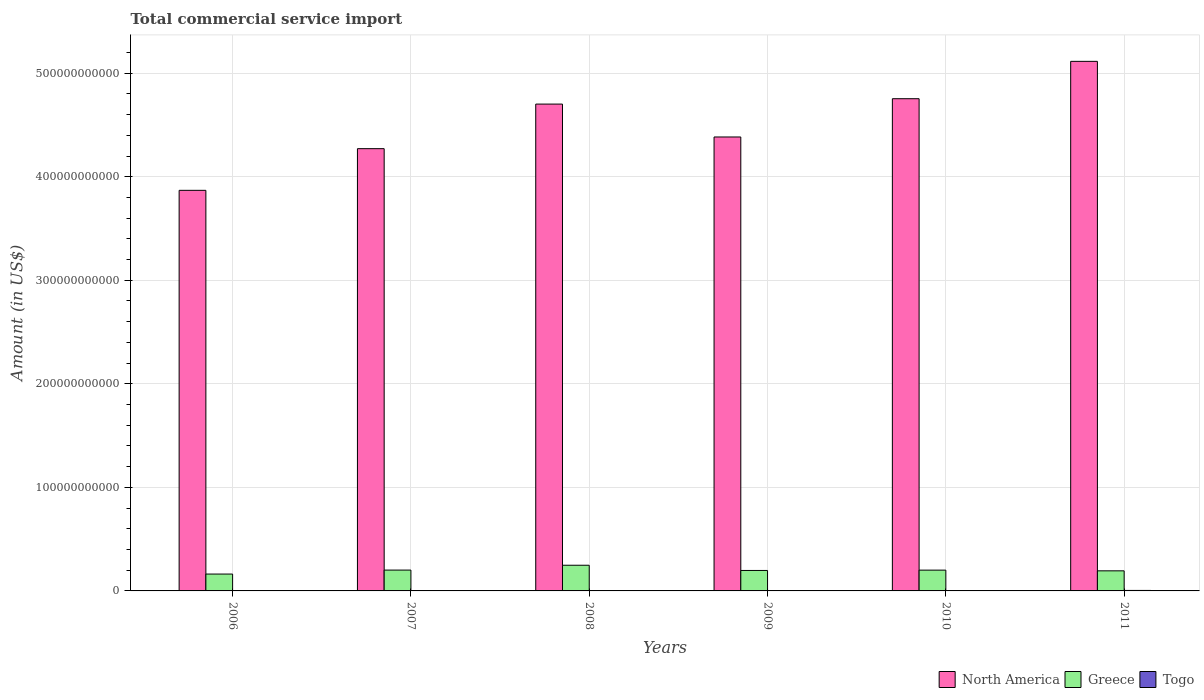How many different coloured bars are there?
Your answer should be very brief. 3. Are the number of bars per tick equal to the number of legend labels?
Give a very brief answer. Yes. Are the number of bars on each tick of the X-axis equal?
Your response must be concise. Yes. How many bars are there on the 2nd tick from the left?
Provide a short and direct response. 3. In how many cases, is the number of bars for a given year not equal to the number of legend labels?
Your answer should be very brief. 0. What is the total commercial service import in Togo in 2011?
Ensure brevity in your answer.  4.67e+08. Across all years, what is the maximum total commercial service import in North America?
Provide a succinct answer. 5.11e+11. Across all years, what is the minimum total commercial service import in North America?
Keep it short and to the point. 3.87e+11. In which year was the total commercial service import in Togo minimum?
Make the answer very short. 2006. What is the total total commercial service import in Greece in the graph?
Your response must be concise. 1.20e+11. What is the difference between the total commercial service import in Greece in 2007 and that in 2010?
Give a very brief answer. 3.73e+07. What is the difference between the total commercial service import in Togo in 2009 and the total commercial service import in Greece in 2006?
Provide a succinct answer. -1.59e+1. What is the average total commercial service import in Togo per year?
Provide a short and direct response. 3.60e+08. In the year 2011, what is the difference between the total commercial service import in Greece and total commercial service import in Togo?
Your response must be concise. 1.89e+1. What is the ratio of the total commercial service import in North America in 2006 to that in 2009?
Provide a succinct answer. 0.88. Is the difference between the total commercial service import in Greece in 2006 and 2008 greater than the difference between the total commercial service import in Togo in 2006 and 2008?
Provide a succinct answer. No. What is the difference between the highest and the second highest total commercial service import in Greece?
Give a very brief answer. 4.68e+09. What is the difference between the highest and the lowest total commercial service import in Greece?
Your response must be concise. 8.51e+09. Is the sum of the total commercial service import in Togo in 2010 and 2011 greater than the maximum total commercial service import in North America across all years?
Keep it short and to the point. No. What does the 3rd bar from the left in 2006 represents?
Offer a terse response. Togo. Is it the case that in every year, the sum of the total commercial service import in Greece and total commercial service import in North America is greater than the total commercial service import in Togo?
Provide a succinct answer. Yes. Are all the bars in the graph horizontal?
Provide a succinct answer. No. How many years are there in the graph?
Your answer should be compact. 6. What is the difference between two consecutive major ticks on the Y-axis?
Make the answer very short. 1.00e+11. Are the values on the major ticks of Y-axis written in scientific E-notation?
Offer a terse response. No. Does the graph contain any zero values?
Provide a succinct answer. No. What is the title of the graph?
Keep it short and to the point. Total commercial service import. Does "Uruguay" appear as one of the legend labels in the graph?
Keep it short and to the point. No. What is the label or title of the X-axis?
Provide a short and direct response. Years. What is the label or title of the Y-axis?
Your response must be concise. Amount (in US$). What is the Amount (in US$) in North America in 2006?
Make the answer very short. 3.87e+11. What is the Amount (in US$) of Greece in 2006?
Keep it short and to the point. 1.63e+1. What is the Amount (in US$) in Togo in 2006?
Your answer should be compact. 2.61e+08. What is the Amount (in US$) in North America in 2007?
Provide a succinct answer. 4.27e+11. What is the Amount (in US$) in Greece in 2007?
Your response must be concise. 2.01e+1. What is the Amount (in US$) in Togo in 2007?
Keep it short and to the point. 3.03e+08. What is the Amount (in US$) in North America in 2008?
Ensure brevity in your answer.  4.70e+11. What is the Amount (in US$) of Greece in 2008?
Ensure brevity in your answer.  2.48e+1. What is the Amount (in US$) in Togo in 2008?
Provide a short and direct response. 3.58e+08. What is the Amount (in US$) in North America in 2009?
Offer a very short reply. 4.38e+11. What is the Amount (in US$) of Greece in 2009?
Provide a short and direct response. 1.98e+1. What is the Amount (in US$) of Togo in 2009?
Provide a succinct answer. 3.74e+08. What is the Amount (in US$) of North America in 2010?
Provide a succinct answer. 4.75e+11. What is the Amount (in US$) of Greece in 2010?
Give a very brief answer. 2.01e+1. What is the Amount (in US$) of Togo in 2010?
Offer a very short reply. 3.95e+08. What is the Amount (in US$) in North America in 2011?
Offer a very short reply. 5.11e+11. What is the Amount (in US$) of Greece in 2011?
Your response must be concise. 1.94e+1. What is the Amount (in US$) of Togo in 2011?
Offer a very short reply. 4.67e+08. Across all years, what is the maximum Amount (in US$) of North America?
Your response must be concise. 5.11e+11. Across all years, what is the maximum Amount (in US$) in Greece?
Provide a short and direct response. 2.48e+1. Across all years, what is the maximum Amount (in US$) in Togo?
Offer a very short reply. 4.67e+08. Across all years, what is the minimum Amount (in US$) of North America?
Your answer should be very brief. 3.87e+11. Across all years, what is the minimum Amount (in US$) of Greece?
Give a very brief answer. 1.63e+1. Across all years, what is the minimum Amount (in US$) of Togo?
Make the answer very short. 2.61e+08. What is the total Amount (in US$) of North America in the graph?
Offer a terse response. 2.71e+12. What is the total Amount (in US$) in Greece in the graph?
Ensure brevity in your answer.  1.20e+11. What is the total Amount (in US$) of Togo in the graph?
Your response must be concise. 2.16e+09. What is the difference between the Amount (in US$) of North America in 2006 and that in 2007?
Your response must be concise. -4.02e+1. What is the difference between the Amount (in US$) in Greece in 2006 and that in 2007?
Provide a short and direct response. -3.83e+09. What is the difference between the Amount (in US$) of Togo in 2006 and that in 2007?
Your answer should be very brief. -4.21e+07. What is the difference between the Amount (in US$) in North America in 2006 and that in 2008?
Keep it short and to the point. -8.33e+1. What is the difference between the Amount (in US$) in Greece in 2006 and that in 2008?
Give a very brief answer. -8.51e+09. What is the difference between the Amount (in US$) in Togo in 2006 and that in 2008?
Ensure brevity in your answer.  -9.65e+07. What is the difference between the Amount (in US$) of North America in 2006 and that in 2009?
Your answer should be compact. -5.15e+1. What is the difference between the Amount (in US$) of Greece in 2006 and that in 2009?
Give a very brief answer. -3.47e+09. What is the difference between the Amount (in US$) in Togo in 2006 and that in 2009?
Your response must be concise. -1.13e+08. What is the difference between the Amount (in US$) of North America in 2006 and that in 2010?
Provide a succinct answer. -8.85e+1. What is the difference between the Amount (in US$) of Greece in 2006 and that in 2010?
Give a very brief answer. -3.79e+09. What is the difference between the Amount (in US$) in Togo in 2006 and that in 2010?
Give a very brief answer. -1.34e+08. What is the difference between the Amount (in US$) of North America in 2006 and that in 2011?
Give a very brief answer. -1.25e+11. What is the difference between the Amount (in US$) of Greece in 2006 and that in 2011?
Your answer should be compact. -3.11e+09. What is the difference between the Amount (in US$) in Togo in 2006 and that in 2011?
Your answer should be very brief. -2.06e+08. What is the difference between the Amount (in US$) in North America in 2007 and that in 2008?
Keep it short and to the point. -4.30e+1. What is the difference between the Amount (in US$) in Greece in 2007 and that in 2008?
Your answer should be compact. -4.68e+09. What is the difference between the Amount (in US$) in Togo in 2007 and that in 2008?
Provide a short and direct response. -5.44e+07. What is the difference between the Amount (in US$) in North America in 2007 and that in 2009?
Offer a terse response. -1.13e+1. What is the difference between the Amount (in US$) of Greece in 2007 and that in 2009?
Ensure brevity in your answer.  3.55e+08. What is the difference between the Amount (in US$) of Togo in 2007 and that in 2009?
Offer a terse response. -7.10e+07. What is the difference between the Amount (in US$) of North America in 2007 and that in 2010?
Ensure brevity in your answer.  -4.82e+1. What is the difference between the Amount (in US$) in Greece in 2007 and that in 2010?
Make the answer very short. 3.73e+07. What is the difference between the Amount (in US$) in Togo in 2007 and that in 2010?
Your answer should be very brief. -9.20e+07. What is the difference between the Amount (in US$) in North America in 2007 and that in 2011?
Your response must be concise. -8.43e+1. What is the difference between the Amount (in US$) in Greece in 2007 and that in 2011?
Offer a terse response. 7.17e+08. What is the difference between the Amount (in US$) in Togo in 2007 and that in 2011?
Your answer should be compact. -1.64e+08. What is the difference between the Amount (in US$) in North America in 2008 and that in 2009?
Ensure brevity in your answer.  3.18e+1. What is the difference between the Amount (in US$) of Greece in 2008 and that in 2009?
Give a very brief answer. 5.04e+09. What is the difference between the Amount (in US$) in Togo in 2008 and that in 2009?
Make the answer very short. -1.66e+07. What is the difference between the Amount (in US$) in North America in 2008 and that in 2010?
Offer a terse response. -5.18e+09. What is the difference between the Amount (in US$) of Greece in 2008 and that in 2010?
Keep it short and to the point. 4.72e+09. What is the difference between the Amount (in US$) in Togo in 2008 and that in 2010?
Your response must be concise. -3.77e+07. What is the difference between the Amount (in US$) in North America in 2008 and that in 2011?
Make the answer very short. -4.13e+1. What is the difference between the Amount (in US$) of Greece in 2008 and that in 2011?
Provide a succinct answer. 5.40e+09. What is the difference between the Amount (in US$) in Togo in 2008 and that in 2011?
Offer a very short reply. -1.10e+08. What is the difference between the Amount (in US$) in North America in 2009 and that in 2010?
Provide a succinct answer. -3.70e+1. What is the difference between the Amount (in US$) of Greece in 2009 and that in 2010?
Give a very brief answer. -3.17e+08. What is the difference between the Amount (in US$) in Togo in 2009 and that in 2010?
Offer a very short reply. -2.11e+07. What is the difference between the Amount (in US$) in North America in 2009 and that in 2011?
Your response must be concise. -7.30e+1. What is the difference between the Amount (in US$) in Greece in 2009 and that in 2011?
Make the answer very short. 3.62e+08. What is the difference between the Amount (in US$) in Togo in 2009 and that in 2011?
Offer a very short reply. -9.32e+07. What is the difference between the Amount (in US$) of North America in 2010 and that in 2011?
Give a very brief answer. -3.61e+1. What is the difference between the Amount (in US$) in Greece in 2010 and that in 2011?
Make the answer very short. 6.79e+08. What is the difference between the Amount (in US$) in Togo in 2010 and that in 2011?
Keep it short and to the point. -7.21e+07. What is the difference between the Amount (in US$) of North America in 2006 and the Amount (in US$) of Greece in 2007?
Your response must be concise. 3.67e+11. What is the difference between the Amount (in US$) of North America in 2006 and the Amount (in US$) of Togo in 2007?
Offer a terse response. 3.87e+11. What is the difference between the Amount (in US$) of Greece in 2006 and the Amount (in US$) of Togo in 2007?
Offer a terse response. 1.60e+1. What is the difference between the Amount (in US$) in North America in 2006 and the Amount (in US$) in Greece in 2008?
Offer a very short reply. 3.62e+11. What is the difference between the Amount (in US$) of North America in 2006 and the Amount (in US$) of Togo in 2008?
Ensure brevity in your answer.  3.86e+11. What is the difference between the Amount (in US$) in Greece in 2006 and the Amount (in US$) in Togo in 2008?
Offer a terse response. 1.59e+1. What is the difference between the Amount (in US$) of North America in 2006 and the Amount (in US$) of Greece in 2009?
Your answer should be compact. 3.67e+11. What is the difference between the Amount (in US$) in North America in 2006 and the Amount (in US$) in Togo in 2009?
Keep it short and to the point. 3.86e+11. What is the difference between the Amount (in US$) of Greece in 2006 and the Amount (in US$) of Togo in 2009?
Your answer should be very brief. 1.59e+1. What is the difference between the Amount (in US$) of North America in 2006 and the Amount (in US$) of Greece in 2010?
Your answer should be compact. 3.67e+11. What is the difference between the Amount (in US$) in North America in 2006 and the Amount (in US$) in Togo in 2010?
Your answer should be compact. 3.86e+11. What is the difference between the Amount (in US$) in Greece in 2006 and the Amount (in US$) in Togo in 2010?
Offer a very short reply. 1.59e+1. What is the difference between the Amount (in US$) of North America in 2006 and the Amount (in US$) of Greece in 2011?
Your answer should be compact. 3.67e+11. What is the difference between the Amount (in US$) in North America in 2006 and the Amount (in US$) in Togo in 2011?
Make the answer very short. 3.86e+11. What is the difference between the Amount (in US$) of Greece in 2006 and the Amount (in US$) of Togo in 2011?
Make the answer very short. 1.58e+1. What is the difference between the Amount (in US$) in North America in 2007 and the Amount (in US$) in Greece in 2008?
Provide a short and direct response. 4.02e+11. What is the difference between the Amount (in US$) of North America in 2007 and the Amount (in US$) of Togo in 2008?
Ensure brevity in your answer.  4.27e+11. What is the difference between the Amount (in US$) of Greece in 2007 and the Amount (in US$) of Togo in 2008?
Your answer should be compact. 1.98e+1. What is the difference between the Amount (in US$) in North America in 2007 and the Amount (in US$) in Greece in 2009?
Make the answer very short. 4.07e+11. What is the difference between the Amount (in US$) of North America in 2007 and the Amount (in US$) of Togo in 2009?
Offer a very short reply. 4.27e+11. What is the difference between the Amount (in US$) in Greece in 2007 and the Amount (in US$) in Togo in 2009?
Give a very brief answer. 1.97e+1. What is the difference between the Amount (in US$) of North America in 2007 and the Amount (in US$) of Greece in 2010?
Ensure brevity in your answer.  4.07e+11. What is the difference between the Amount (in US$) in North America in 2007 and the Amount (in US$) in Togo in 2010?
Provide a short and direct response. 4.27e+11. What is the difference between the Amount (in US$) of Greece in 2007 and the Amount (in US$) of Togo in 2010?
Offer a terse response. 1.97e+1. What is the difference between the Amount (in US$) of North America in 2007 and the Amount (in US$) of Greece in 2011?
Provide a succinct answer. 4.08e+11. What is the difference between the Amount (in US$) in North America in 2007 and the Amount (in US$) in Togo in 2011?
Ensure brevity in your answer.  4.27e+11. What is the difference between the Amount (in US$) of Greece in 2007 and the Amount (in US$) of Togo in 2011?
Offer a terse response. 1.96e+1. What is the difference between the Amount (in US$) of North America in 2008 and the Amount (in US$) of Greece in 2009?
Provide a succinct answer. 4.50e+11. What is the difference between the Amount (in US$) in North America in 2008 and the Amount (in US$) in Togo in 2009?
Your response must be concise. 4.70e+11. What is the difference between the Amount (in US$) of Greece in 2008 and the Amount (in US$) of Togo in 2009?
Provide a succinct answer. 2.44e+1. What is the difference between the Amount (in US$) in North America in 2008 and the Amount (in US$) in Greece in 2010?
Your answer should be compact. 4.50e+11. What is the difference between the Amount (in US$) of North America in 2008 and the Amount (in US$) of Togo in 2010?
Give a very brief answer. 4.70e+11. What is the difference between the Amount (in US$) in Greece in 2008 and the Amount (in US$) in Togo in 2010?
Your answer should be compact. 2.44e+1. What is the difference between the Amount (in US$) of North America in 2008 and the Amount (in US$) of Greece in 2011?
Provide a succinct answer. 4.51e+11. What is the difference between the Amount (in US$) in North America in 2008 and the Amount (in US$) in Togo in 2011?
Offer a terse response. 4.70e+11. What is the difference between the Amount (in US$) of Greece in 2008 and the Amount (in US$) of Togo in 2011?
Your answer should be compact. 2.43e+1. What is the difference between the Amount (in US$) of North America in 2009 and the Amount (in US$) of Greece in 2010?
Keep it short and to the point. 4.18e+11. What is the difference between the Amount (in US$) in North America in 2009 and the Amount (in US$) in Togo in 2010?
Your answer should be compact. 4.38e+11. What is the difference between the Amount (in US$) in Greece in 2009 and the Amount (in US$) in Togo in 2010?
Give a very brief answer. 1.94e+1. What is the difference between the Amount (in US$) in North America in 2009 and the Amount (in US$) in Greece in 2011?
Make the answer very short. 4.19e+11. What is the difference between the Amount (in US$) of North America in 2009 and the Amount (in US$) of Togo in 2011?
Offer a terse response. 4.38e+11. What is the difference between the Amount (in US$) in Greece in 2009 and the Amount (in US$) in Togo in 2011?
Give a very brief answer. 1.93e+1. What is the difference between the Amount (in US$) in North America in 2010 and the Amount (in US$) in Greece in 2011?
Offer a terse response. 4.56e+11. What is the difference between the Amount (in US$) of North America in 2010 and the Amount (in US$) of Togo in 2011?
Offer a very short reply. 4.75e+11. What is the difference between the Amount (in US$) in Greece in 2010 and the Amount (in US$) in Togo in 2011?
Your answer should be very brief. 1.96e+1. What is the average Amount (in US$) in North America per year?
Your response must be concise. 4.52e+11. What is the average Amount (in US$) in Greece per year?
Your response must be concise. 2.01e+1. What is the average Amount (in US$) in Togo per year?
Your answer should be very brief. 3.60e+08. In the year 2006, what is the difference between the Amount (in US$) in North America and Amount (in US$) in Greece?
Your response must be concise. 3.71e+11. In the year 2006, what is the difference between the Amount (in US$) of North America and Amount (in US$) of Togo?
Your answer should be compact. 3.87e+11. In the year 2006, what is the difference between the Amount (in US$) in Greece and Amount (in US$) in Togo?
Your answer should be very brief. 1.60e+1. In the year 2007, what is the difference between the Amount (in US$) of North America and Amount (in US$) of Greece?
Offer a very short reply. 4.07e+11. In the year 2007, what is the difference between the Amount (in US$) of North America and Amount (in US$) of Togo?
Provide a short and direct response. 4.27e+11. In the year 2007, what is the difference between the Amount (in US$) of Greece and Amount (in US$) of Togo?
Offer a very short reply. 1.98e+1. In the year 2008, what is the difference between the Amount (in US$) in North America and Amount (in US$) in Greece?
Your answer should be compact. 4.45e+11. In the year 2008, what is the difference between the Amount (in US$) in North America and Amount (in US$) in Togo?
Offer a very short reply. 4.70e+11. In the year 2008, what is the difference between the Amount (in US$) in Greece and Amount (in US$) in Togo?
Provide a short and direct response. 2.44e+1. In the year 2009, what is the difference between the Amount (in US$) in North America and Amount (in US$) in Greece?
Your answer should be very brief. 4.19e+11. In the year 2009, what is the difference between the Amount (in US$) in North America and Amount (in US$) in Togo?
Your response must be concise. 4.38e+11. In the year 2009, what is the difference between the Amount (in US$) in Greece and Amount (in US$) in Togo?
Ensure brevity in your answer.  1.94e+1. In the year 2010, what is the difference between the Amount (in US$) of North America and Amount (in US$) of Greece?
Offer a very short reply. 4.55e+11. In the year 2010, what is the difference between the Amount (in US$) of North America and Amount (in US$) of Togo?
Your answer should be very brief. 4.75e+11. In the year 2010, what is the difference between the Amount (in US$) in Greece and Amount (in US$) in Togo?
Your answer should be compact. 1.97e+1. In the year 2011, what is the difference between the Amount (in US$) in North America and Amount (in US$) in Greece?
Keep it short and to the point. 4.92e+11. In the year 2011, what is the difference between the Amount (in US$) of North America and Amount (in US$) of Togo?
Provide a succinct answer. 5.11e+11. In the year 2011, what is the difference between the Amount (in US$) in Greece and Amount (in US$) in Togo?
Keep it short and to the point. 1.89e+1. What is the ratio of the Amount (in US$) in North America in 2006 to that in 2007?
Provide a succinct answer. 0.91. What is the ratio of the Amount (in US$) of Greece in 2006 to that in 2007?
Offer a very short reply. 0.81. What is the ratio of the Amount (in US$) of Togo in 2006 to that in 2007?
Your response must be concise. 0.86. What is the ratio of the Amount (in US$) in North America in 2006 to that in 2008?
Ensure brevity in your answer.  0.82. What is the ratio of the Amount (in US$) in Greece in 2006 to that in 2008?
Your answer should be compact. 0.66. What is the ratio of the Amount (in US$) of Togo in 2006 to that in 2008?
Make the answer very short. 0.73. What is the ratio of the Amount (in US$) in North America in 2006 to that in 2009?
Your answer should be very brief. 0.88. What is the ratio of the Amount (in US$) in Greece in 2006 to that in 2009?
Offer a terse response. 0.82. What is the ratio of the Amount (in US$) of Togo in 2006 to that in 2009?
Your response must be concise. 0.7. What is the ratio of the Amount (in US$) in North America in 2006 to that in 2010?
Your answer should be very brief. 0.81. What is the ratio of the Amount (in US$) in Greece in 2006 to that in 2010?
Keep it short and to the point. 0.81. What is the ratio of the Amount (in US$) in Togo in 2006 to that in 2010?
Give a very brief answer. 0.66. What is the ratio of the Amount (in US$) in North America in 2006 to that in 2011?
Keep it short and to the point. 0.76. What is the ratio of the Amount (in US$) of Greece in 2006 to that in 2011?
Make the answer very short. 0.84. What is the ratio of the Amount (in US$) in Togo in 2006 to that in 2011?
Ensure brevity in your answer.  0.56. What is the ratio of the Amount (in US$) of North America in 2007 to that in 2008?
Offer a terse response. 0.91. What is the ratio of the Amount (in US$) of Greece in 2007 to that in 2008?
Keep it short and to the point. 0.81. What is the ratio of the Amount (in US$) in Togo in 2007 to that in 2008?
Ensure brevity in your answer.  0.85. What is the ratio of the Amount (in US$) in North America in 2007 to that in 2009?
Your answer should be very brief. 0.97. What is the ratio of the Amount (in US$) of Greece in 2007 to that in 2009?
Provide a succinct answer. 1.02. What is the ratio of the Amount (in US$) in Togo in 2007 to that in 2009?
Provide a succinct answer. 0.81. What is the ratio of the Amount (in US$) of North America in 2007 to that in 2010?
Offer a very short reply. 0.9. What is the ratio of the Amount (in US$) in Greece in 2007 to that in 2010?
Your response must be concise. 1. What is the ratio of the Amount (in US$) of Togo in 2007 to that in 2010?
Offer a terse response. 0.77. What is the ratio of the Amount (in US$) in North America in 2007 to that in 2011?
Ensure brevity in your answer.  0.84. What is the ratio of the Amount (in US$) in Greece in 2007 to that in 2011?
Ensure brevity in your answer.  1.04. What is the ratio of the Amount (in US$) of Togo in 2007 to that in 2011?
Provide a short and direct response. 0.65. What is the ratio of the Amount (in US$) in North America in 2008 to that in 2009?
Your response must be concise. 1.07. What is the ratio of the Amount (in US$) in Greece in 2008 to that in 2009?
Ensure brevity in your answer.  1.25. What is the ratio of the Amount (in US$) in Togo in 2008 to that in 2009?
Your answer should be compact. 0.96. What is the ratio of the Amount (in US$) of Greece in 2008 to that in 2010?
Provide a succinct answer. 1.24. What is the ratio of the Amount (in US$) of Togo in 2008 to that in 2010?
Provide a short and direct response. 0.9. What is the ratio of the Amount (in US$) in North America in 2008 to that in 2011?
Keep it short and to the point. 0.92. What is the ratio of the Amount (in US$) in Greece in 2008 to that in 2011?
Your answer should be very brief. 1.28. What is the ratio of the Amount (in US$) of Togo in 2008 to that in 2011?
Make the answer very short. 0.77. What is the ratio of the Amount (in US$) in North America in 2009 to that in 2010?
Offer a terse response. 0.92. What is the ratio of the Amount (in US$) of Greece in 2009 to that in 2010?
Keep it short and to the point. 0.98. What is the ratio of the Amount (in US$) of Togo in 2009 to that in 2010?
Offer a terse response. 0.95. What is the ratio of the Amount (in US$) in North America in 2009 to that in 2011?
Keep it short and to the point. 0.86. What is the ratio of the Amount (in US$) of Greece in 2009 to that in 2011?
Ensure brevity in your answer.  1.02. What is the ratio of the Amount (in US$) of Togo in 2009 to that in 2011?
Offer a terse response. 0.8. What is the ratio of the Amount (in US$) in North America in 2010 to that in 2011?
Your answer should be compact. 0.93. What is the ratio of the Amount (in US$) in Greece in 2010 to that in 2011?
Keep it short and to the point. 1.03. What is the ratio of the Amount (in US$) of Togo in 2010 to that in 2011?
Ensure brevity in your answer.  0.85. What is the difference between the highest and the second highest Amount (in US$) in North America?
Your answer should be very brief. 3.61e+1. What is the difference between the highest and the second highest Amount (in US$) of Greece?
Offer a very short reply. 4.68e+09. What is the difference between the highest and the second highest Amount (in US$) in Togo?
Make the answer very short. 7.21e+07. What is the difference between the highest and the lowest Amount (in US$) of North America?
Ensure brevity in your answer.  1.25e+11. What is the difference between the highest and the lowest Amount (in US$) of Greece?
Make the answer very short. 8.51e+09. What is the difference between the highest and the lowest Amount (in US$) in Togo?
Offer a very short reply. 2.06e+08. 